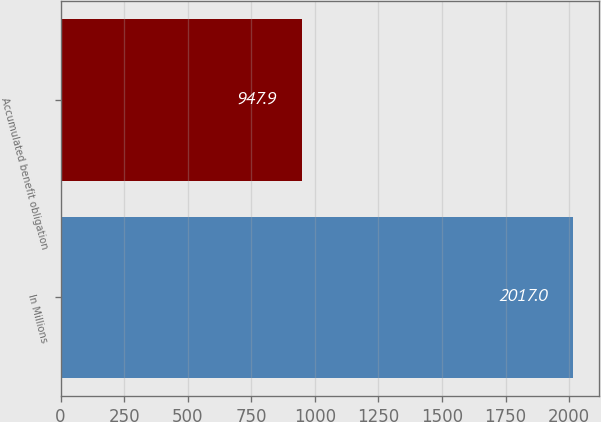Convert chart. <chart><loc_0><loc_0><loc_500><loc_500><bar_chart><fcel>In Millions<fcel>Accumulated benefit obligation<nl><fcel>2017<fcel>947.9<nl></chart> 